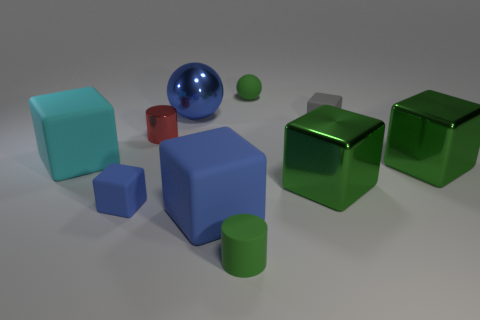Subtract all gray matte cubes. How many cubes are left? 5 Subtract all cylinders. How many objects are left? 8 Subtract all cyan blocks. How many blocks are left? 5 Subtract all gray cubes. Subtract all green balls. How many cubes are left? 5 Subtract all red spheres. How many yellow blocks are left? 0 Subtract all big cyan matte blocks. Subtract all large blue shiny things. How many objects are left? 8 Add 1 tiny blue rubber things. How many tiny blue rubber things are left? 2 Add 8 cyan matte objects. How many cyan matte objects exist? 9 Subtract 0 yellow balls. How many objects are left? 10 Subtract 1 cylinders. How many cylinders are left? 1 